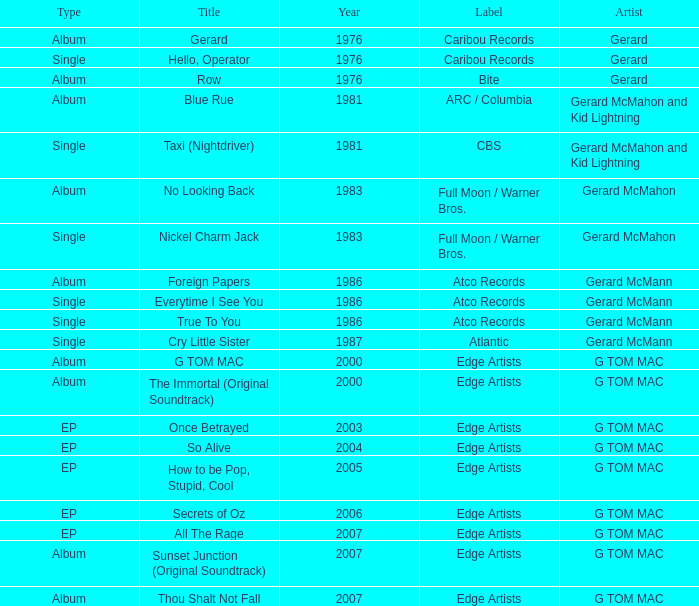Which type has a title of so alive? EP. 